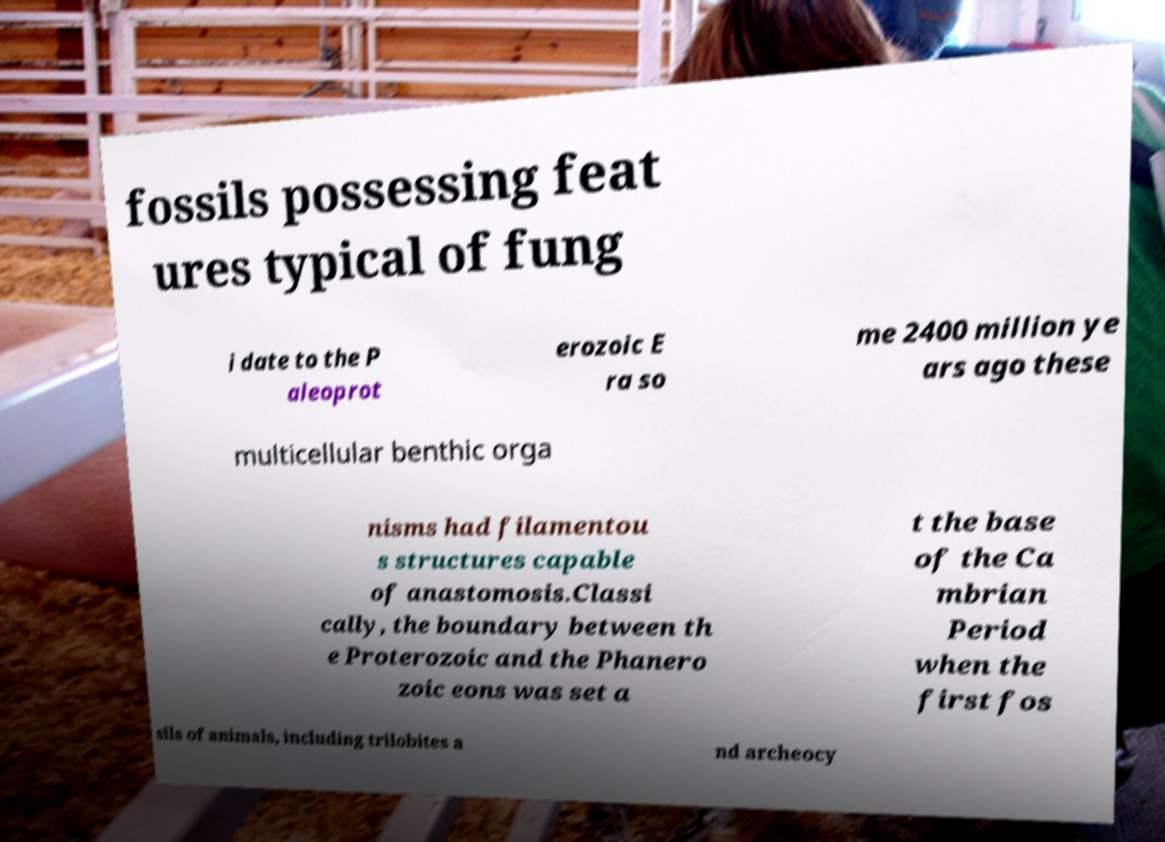Can you accurately transcribe the text from the provided image for me? fossils possessing feat ures typical of fung i date to the P aleoprot erozoic E ra so me 2400 million ye ars ago these multicellular benthic orga nisms had filamentou s structures capable of anastomosis.Classi cally, the boundary between th e Proterozoic and the Phanero zoic eons was set a t the base of the Ca mbrian Period when the first fos sils of animals, including trilobites a nd archeocy 